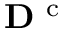<formula> <loc_0><loc_0><loc_500><loc_500>{ D } ^ { c }</formula> 